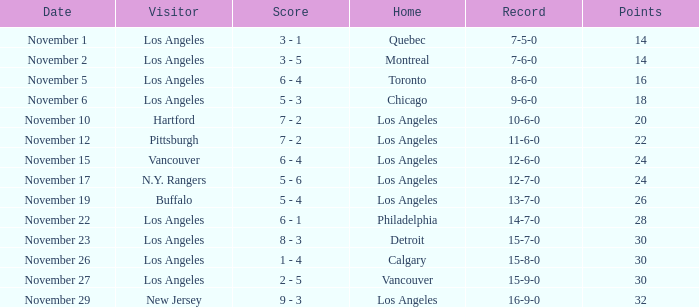What is the record of the game on November 22? 14-7-0. 